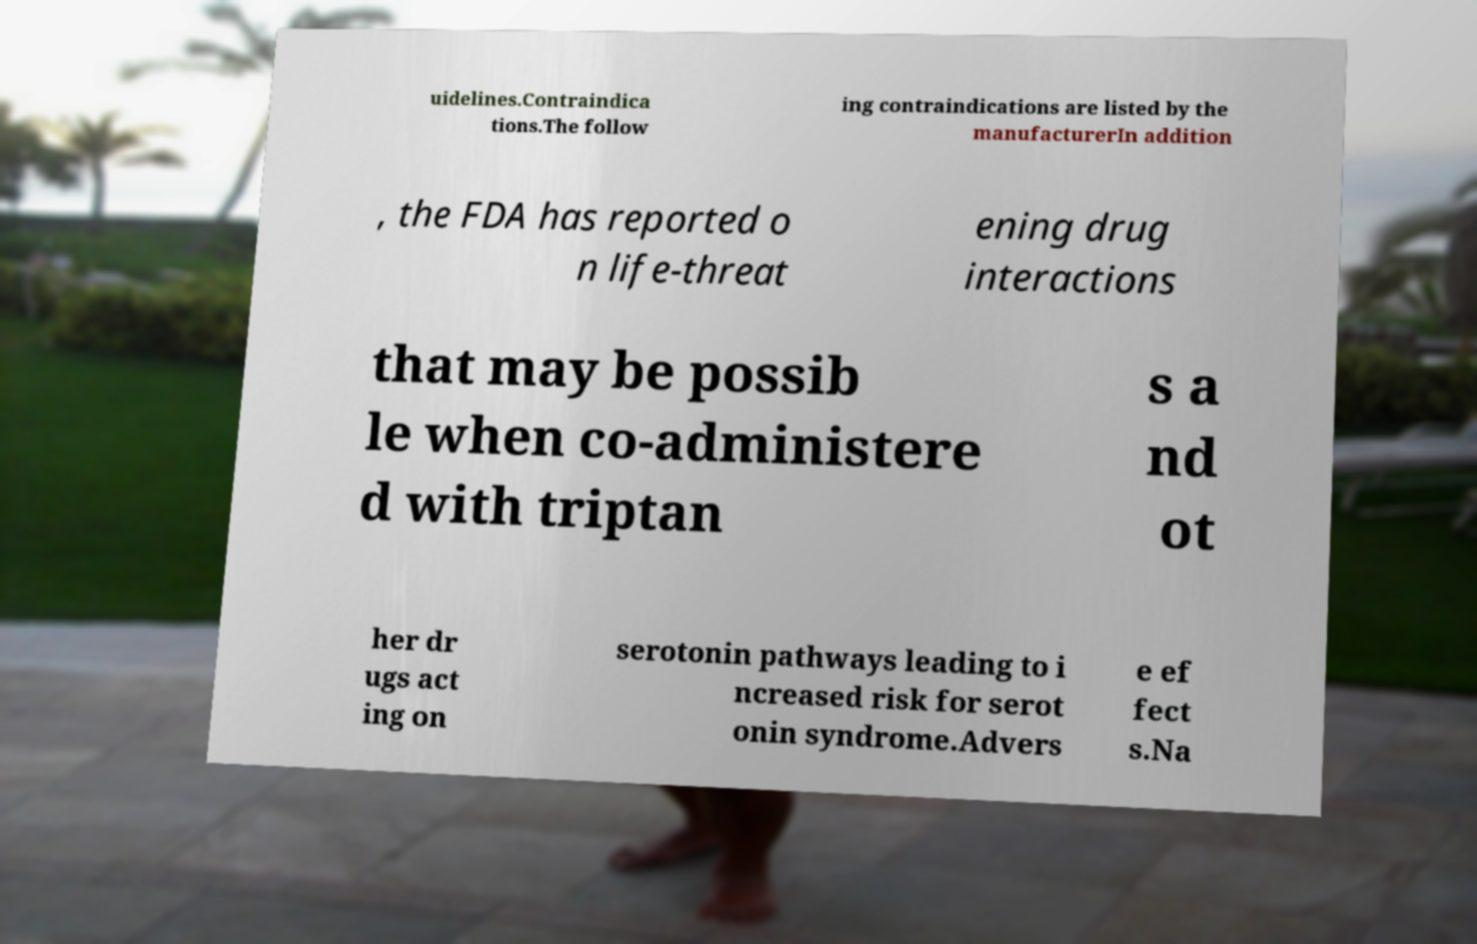Please read and relay the text visible in this image. What does it say? uidelines.Contraindica tions.The follow ing contraindications are listed by the manufacturerIn addition , the FDA has reported o n life-threat ening drug interactions that may be possib le when co-administere d with triptan s a nd ot her dr ugs act ing on serotonin pathways leading to i ncreased risk for serot onin syndrome.Advers e ef fect s.Na 